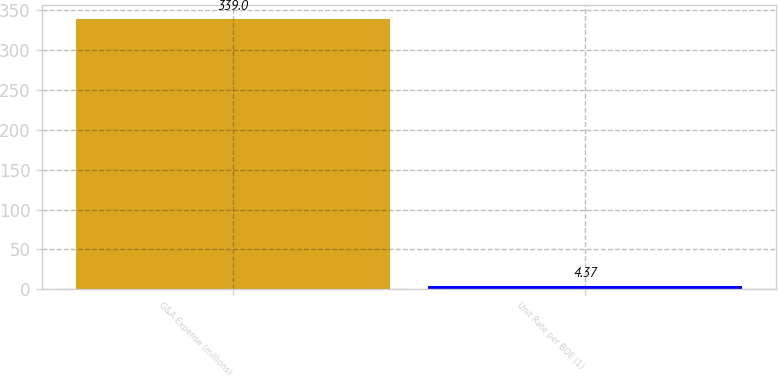Convert chart. <chart><loc_0><loc_0><loc_500><loc_500><bar_chart><fcel>G&A Expense (millions)<fcel>Unit Rate per BOE (1)<nl><fcel>339<fcel>4.37<nl></chart> 